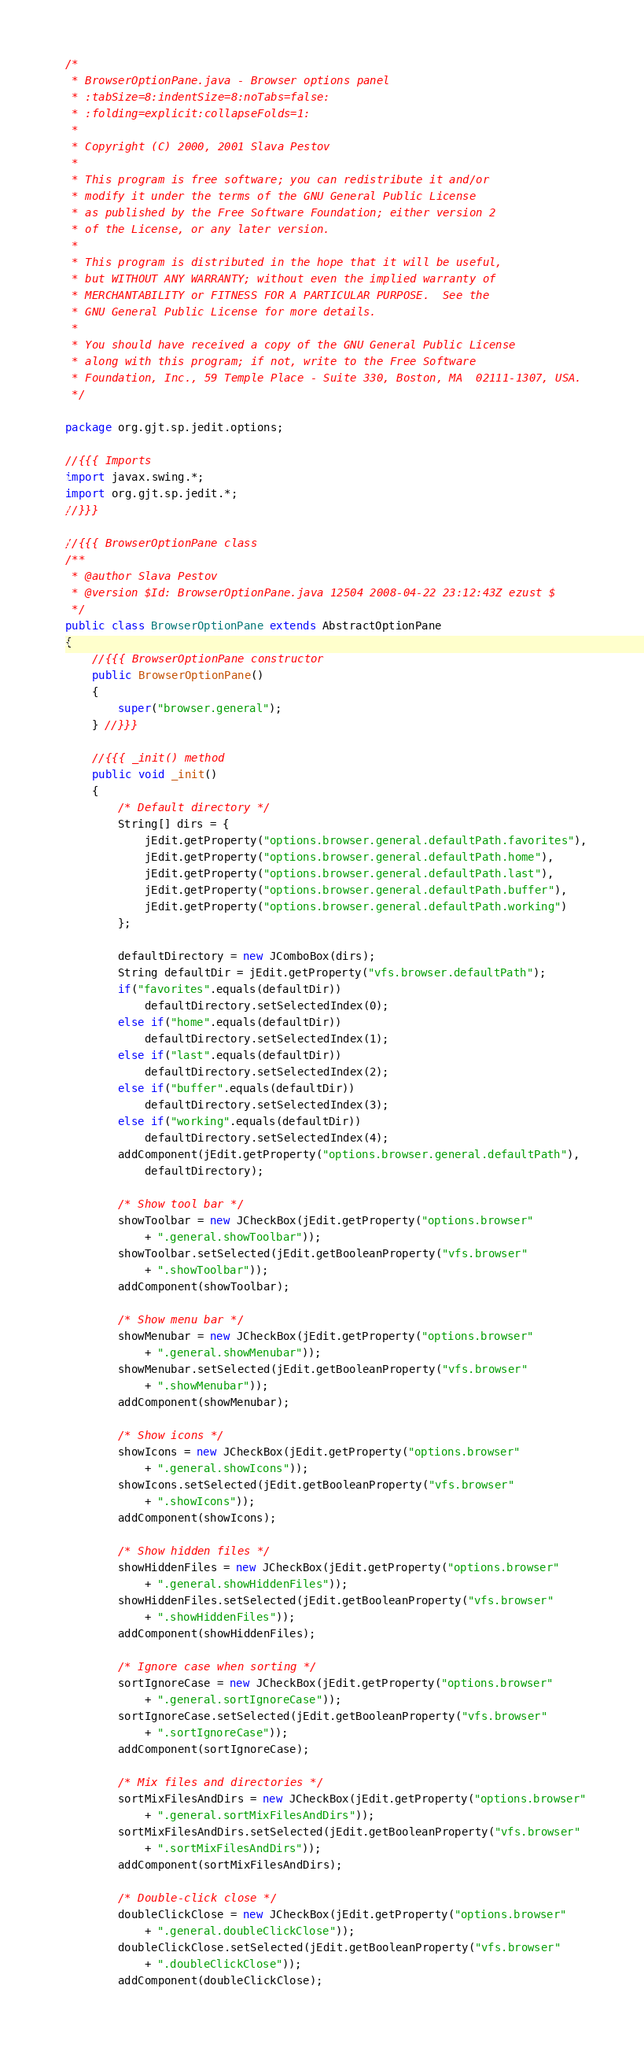Convert code to text. <code><loc_0><loc_0><loc_500><loc_500><_Java_>/*
 * BrowserOptionPane.java - Browser options panel
 * :tabSize=8:indentSize=8:noTabs=false:
 * :folding=explicit:collapseFolds=1:
 *
 * Copyright (C) 2000, 2001 Slava Pestov
 *
 * This program is free software; you can redistribute it and/or
 * modify it under the terms of the GNU General Public License
 * as published by the Free Software Foundation; either version 2
 * of the License, or any later version.
 *
 * This program is distributed in the hope that it will be useful,
 * but WITHOUT ANY WARRANTY; without even the implied warranty of
 * MERCHANTABILITY or FITNESS FOR A PARTICULAR PURPOSE.  See the
 * GNU General Public License for more details.
 *
 * You should have received a copy of the GNU General Public License
 * along with this program; if not, write to the Free Software
 * Foundation, Inc., 59 Temple Place - Suite 330, Boston, MA  02111-1307, USA.
 */

package org.gjt.sp.jedit.options;

//{{{ Imports
import javax.swing.*;
import org.gjt.sp.jedit.*;
//}}}

//{{{ BrowserOptionPane class
/**
 * @author Slava Pestov
 * @version $Id: BrowserOptionPane.java 12504 2008-04-22 23:12:43Z ezust $
 */
public class BrowserOptionPane extends AbstractOptionPane
{
	//{{{ BrowserOptionPane constructor
	public BrowserOptionPane()
	{
		super("browser.general");
	} //}}}

	//{{{ _init() method
	public void _init()
	{
		/* Default directory */
		String[] dirs = {
			jEdit.getProperty("options.browser.general.defaultPath.favorites"),
			jEdit.getProperty("options.browser.general.defaultPath.home"),
			jEdit.getProperty("options.browser.general.defaultPath.last"),
			jEdit.getProperty("options.browser.general.defaultPath.buffer"),
			jEdit.getProperty("options.browser.general.defaultPath.working")
		};

		defaultDirectory = new JComboBox(dirs);
		String defaultDir = jEdit.getProperty("vfs.browser.defaultPath");
		if("favorites".equals(defaultDir))
			defaultDirectory.setSelectedIndex(0);
		else if("home".equals(defaultDir))
			defaultDirectory.setSelectedIndex(1);
		else if("last".equals(defaultDir))
			defaultDirectory.setSelectedIndex(2);
		else if("buffer".equals(defaultDir))
			defaultDirectory.setSelectedIndex(3);
		else if("working".equals(defaultDir))
			defaultDirectory.setSelectedIndex(4);
		addComponent(jEdit.getProperty("options.browser.general.defaultPath"),
			defaultDirectory);

		/* Show tool bar */
		showToolbar = new JCheckBox(jEdit.getProperty("options.browser"
			+ ".general.showToolbar"));
		showToolbar.setSelected(jEdit.getBooleanProperty("vfs.browser"
			+ ".showToolbar"));
		addComponent(showToolbar);

		/* Show menu bar */
		showMenubar = new JCheckBox(jEdit.getProperty("options.browser"
			+ ".general.showMenubar"));
		showMenubar.setSelected(jEdit.getBooleanProperty("vfs.browser"
			+ ".showMenubar"));
		addComponent(showMenubar);

		/* Show icons */
		showIcons = new JCheckBox(jEdit.getProperty("options.browser"
			+ ".general.showIcons"));
		showIcons.setSelected(jEdit.getBooleanProperty("vfs.browser"
			+ ".showIcons"));
		addComponent(showIcons);

		/* Show hidden files */
		showHiddenFiles = new JCheckBox(jEdit.getProperty("options.browser"
			+ ".general.showHiddenFiles"));
		showHiddenFiles.setSelected(jEdit.getBooleanProperty("vfs.browser"
			+ ".showHiddenFiles"));
		addComponent(showHiddenFiles);

		/* Ignore case when sorting */
		sortIgnoreCase = new JCheckBox(jEdit.getProperty("options.browser"
			+ ".general.sortIgnoreCase"));
		sortIgnoreCase.setSelected(jEdit.getBooleanProperty("vfs.browser"
			+ ".sortIgnoreCase"));
		addComponent(sortIgnoreCase);

		/* Mix files and directories */
		sortMixFilesAndDirs = new JCheckBox(jEdit.getProperty("options.browser"
			+ ".general.sortMixFilesAndDirs"));
		sortMixFilesAndDirs.setSelected(jEdit.getBooleanProperty("vfs.browser"
			+ ".sortMixFilesAndDirs"));
		addComponent(sortMixFilesAndDirs);

		/* Double-click close */
		doubleClickClose = new JCheckBox(jEdit.getProperty("options.browser"
			+ ".general.doubleClickClose"));
		doubleClickClose.setSelected(jEdit.getBooleanProperty("vfs.browser"
			+ ".doubleClickClose"));
		addComponent(doubleClickClose);
</code> 